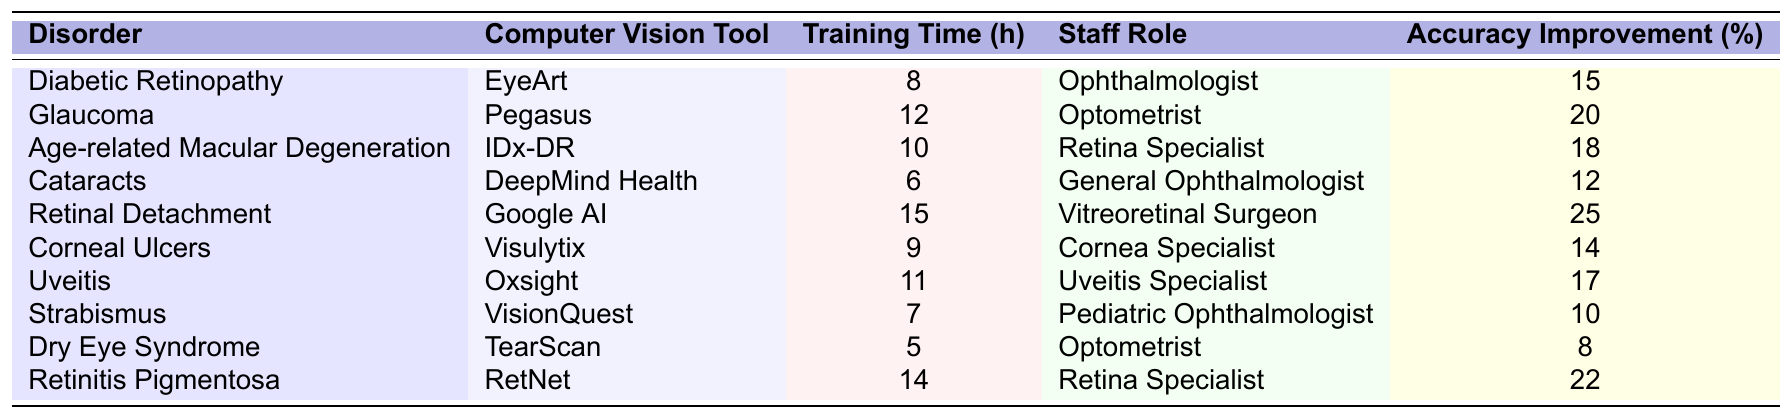What is the training time required for diagnosing Cataracts? The table shows that the training time required for diagnosing Cataracts using the DeepMind Health tool is 6 hours.
Answer: 6 hours Which visual disorder requires the most training time for its diagnosis? By comparing the training times of all the disorders listed in the table, Retinal Detachment requires the most time at 15 hours.
Answer: Retinal Detachment What is the accuracy improvement percentage for the tool used in diagnosing Glaucoma? The table indicates that the accuracy improvement percentage for the Pegasus tool used in diagnosing Glaucoma is 20%.
Answer: 20% How many hours of training are required for Optometrists to use the computer vision tool for Dry Eye Syndrome? The table specifies that the training time required for Optometrists to use the TearScan tool for Dry Eye Syndrome is 5 hours.
Answer: 5 hours What is the average training time across all visual disorders listed? To find the average training time, sum the training times: (8 + 12 + 10 + 6 + 15 + 9 + 11 + 7 + 5 + 14) = 87 hours. There are 10 data points, so the average is 87/10 = 8.7 hours.
Answer: 8.7 hours Is the accuracy improvement for Strabismus greater than that for Corneal Ulcers? The accuracy improvement for Strabismus is 10%, and for Corneal Ulcers, it is 14%. Since 10% is less than 14%, the statement is false.
Answer: No Which staff role requires the least training time for computer vision tools? By reviewing the table, the General Ophthalmologist requires the least training time of 6 hours for diagnosing Cataracts.
Answer: General Ophthalmologist What is the total training time required for the Retina Specialists to learn their computer vision tools? The training times for Retina Specialists are 10 hours (for Age-related Macular Degeneration) and 14 hours (for Retinitis Pigmentosa). Adding them gives 10 + 14 = 24 hours.
Answer: 24 hours Which visual disorder has the highest accuracy improvement percentage, and what is that percentage? The disorder with the highest accuracy improvement is Retinal Detachment with a percentage of 25%.
Answer: Retinal Detachment, 25% Is there a computer vision tool that requires less than 10 hours of training? Yes, upon checking the table, both the DeepMind Health tool for Cataracts (6 hours) and the TearScan tool for Dry Eye Syndrome (5 hours) require less than 10 hours of training.
Answer: Yes 